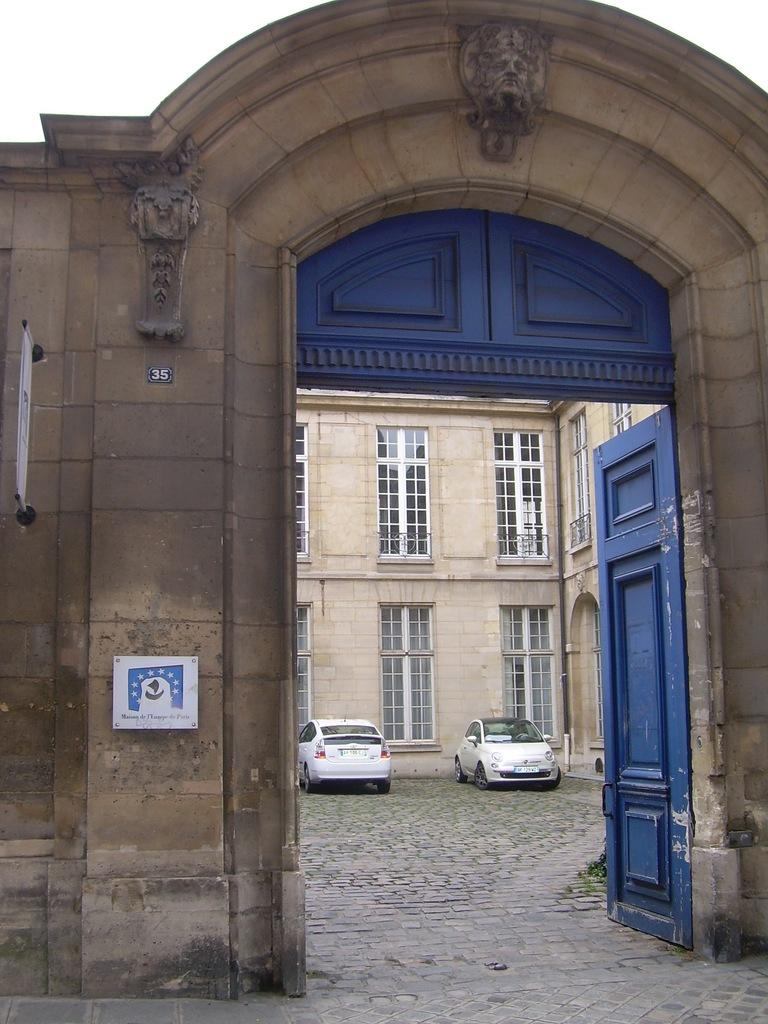What type of structure is visible in the image? There is a building in the image. Can you describe a specific feature of the building? There are glass windows on the building in the image. What else can be seen near the building? There are cars parked in the image. Are there any other notable features on the building? There is a wall with a door in the image. What is attached to the wall? There are boards on the wall in the image. Can you see a tiger walking on the roof of the building in the image? No, there is no tiger present in the image. 